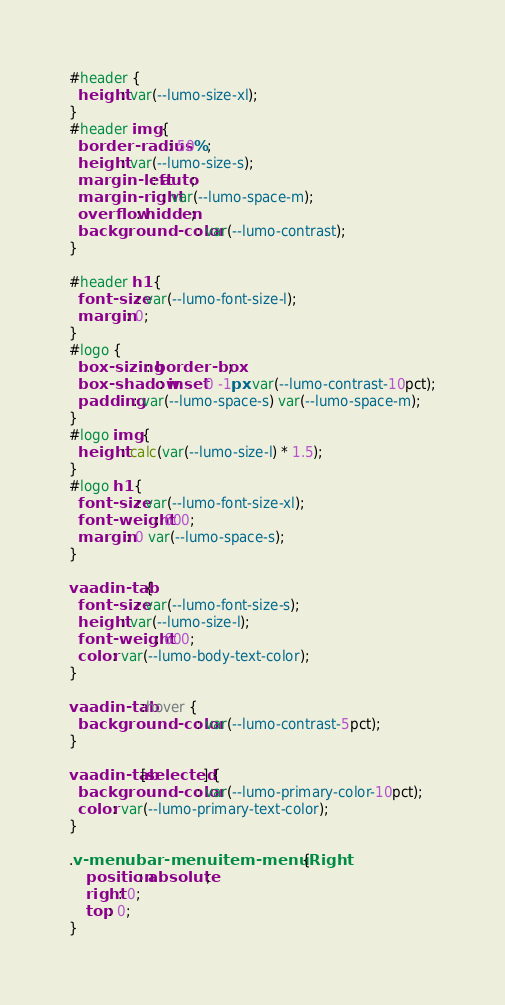<code> <loc_0><loc_0><loc_500><loc_500><_CSS_>#header {
  height: var(--lumo-size-xl);
}
#header img {
  border-radius: 50%;
  height: var(--lumo-size-s);
  margin-left: auto;
  margin-right: var(--lumo-space-m);
  overflow: hidden;
  background-color: var(--lumo-contrast);
}

#header h1 {
  font-size: var(--lumo-font-size-l);
  margin: 0;
}
#logo {
  box-sizing: border-box;
  box-shadow: inset 0 -1px var(--lumo-contrast-10pct);
  padding: var(--lumo-space-s) var(--lumo-space-m);
}
#logo img {
  height: calc(var(--lumo-size-l) * 1.5);
}
#logo h1 {
  font-size: var(--lumo-font-size-xl);
  font-weight: 600;
  margin: 0 var(--lumo-space-s);
}

vaadin-tab {
  font-size: var(--lumo-font-size-s);
  height: var(--lumo-size-l);
  font-weight: 600;
  color: var(--lumo-body-text-color);
}

vaadin-tab:hover {
  background-color: var(--lumo-contrast-5pct);
}

vaadin-tab[selected] {
  background-color: var(--lumo-primary-color-10pct);
  color: var(--lumo-primary-text-color);
}

.v-menubar-menuitem-menuRight {
	position: absolute;
	right: 0;
	top: 0;
}</code> 